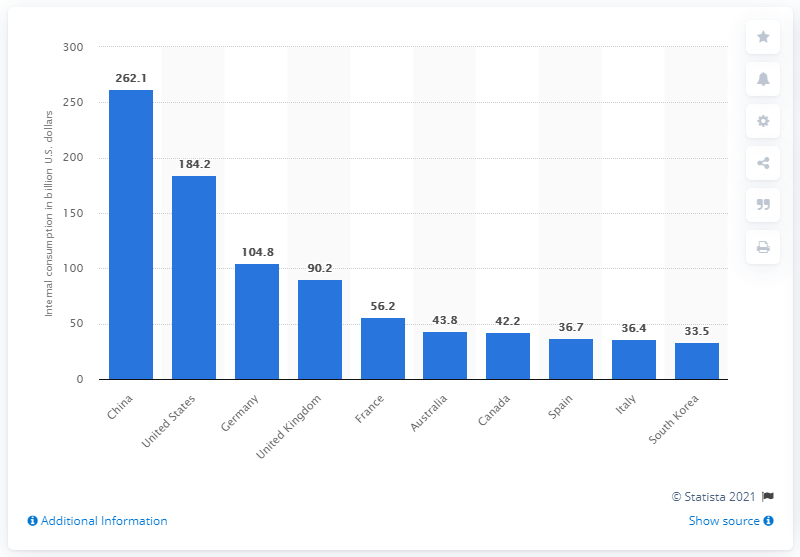Give some essential details in this illustration. In 2019, China's outbound travel and tourism consumption reached 262.1 billion U.S. dollars, indicating a significant increase from the previous year. In 2019, the total outbound expenditure of the United States was 184.2 billion dollars. 